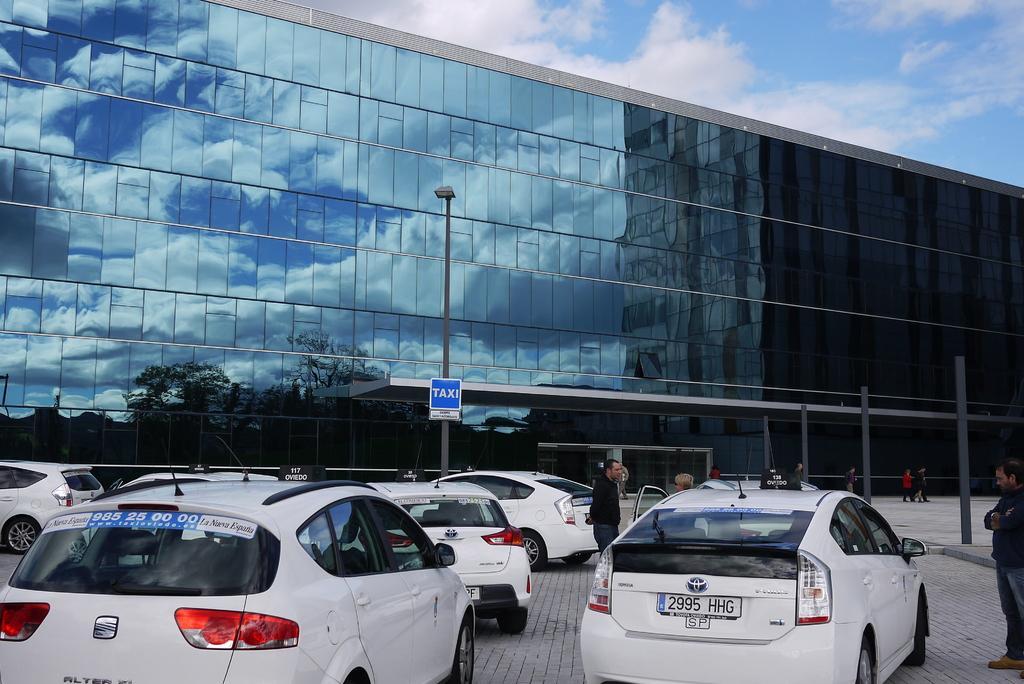Describe this image in one or two sentences. In this image there is a building in the middle. To the building there are glasses. At the top there is the sky. At the bottom there are so many cars parked on the road. In front of them there is a pole on which there is a board. On the right side there are few people walking on the pavement. There are poles in front of the building. 